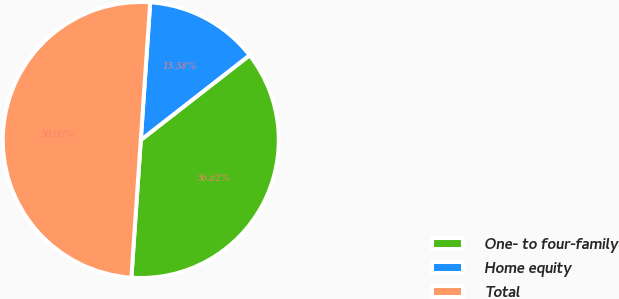Convert chart to OTSL. <chart><loc_0><loc_0><loc_500><loc_500><pie_chart><fcel>One- to four-family<fcel>Home equity<fcel>Total<nl><fcel>36.62%<fcel>13.38%<fcel>50.0%<nl></chart> 